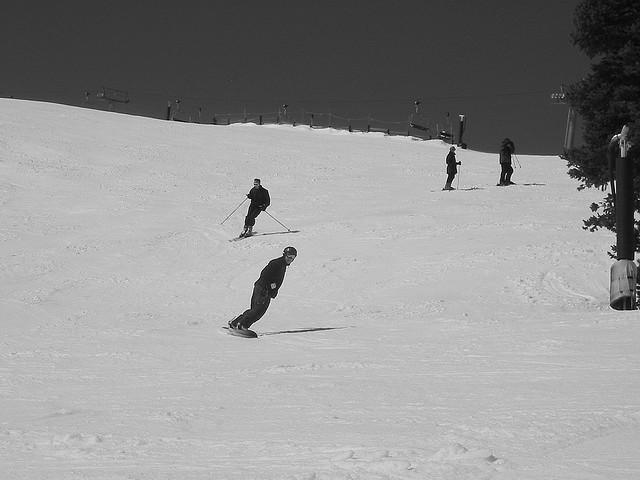How many people are skiing?
Quick response, please. 4. What color is the sky?
Keep it brief. Gray. How many people are on the ski lift on the left?
Write a very short answer. 0. Are they all skiing?
Answer briefly. Yes. What happened right before this pic was taken?
Be succinct. Skiing. Is someone doing a trick?
Answer briefly. No. Are they going up or down the slope?
Write a very short answer. Down. Are these people all going in the same direction?
Be succinct. Yes. Is this person skiing with friends?
Short answer required. Yes. What sport is this onlooker attempting?
Give a very brief answer. Skiing. Which snowboarder is closest to the ground?
Write a very short answer. One in black jacket. How many people can be counted in this photo?
Write a very short answer. 4. Are these people cross-country skiing?
Short answer required. No. Is the man snowboarding?
Answer briefly. Yes. How many people are in the photo?
Short answer required. 4. What time of day is this?
Write a very short answer. Evening. How many people are snowboarding?
Be succinct. 1. Is it sunny?
Be succinct. No. Is this a snowboard?
Give a very brief answer. Yes. Is there sun in the sky?
Keep it brief. No. How many people are shown?
Be succinct. 4. 